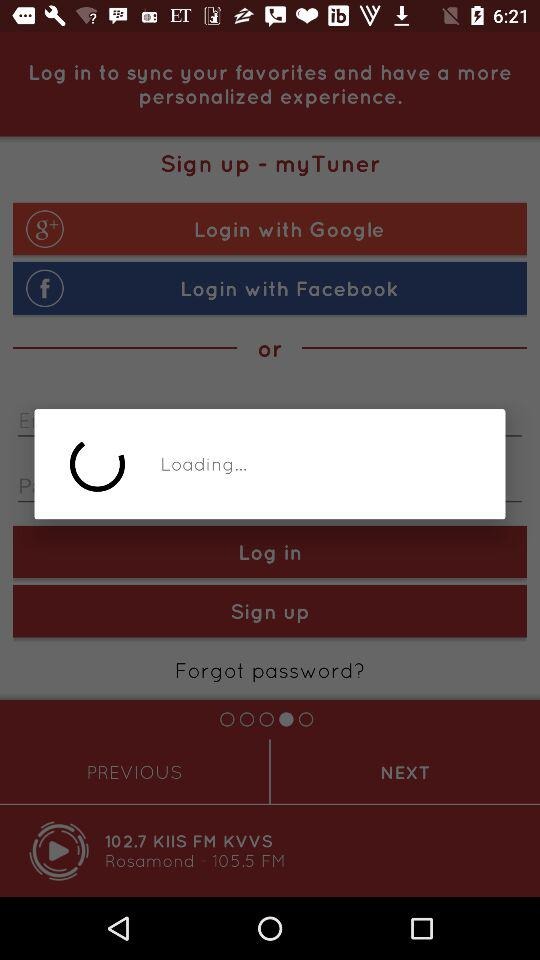What is the frequency of "KIIS FM KVVS"? The frequency is 105.5. 